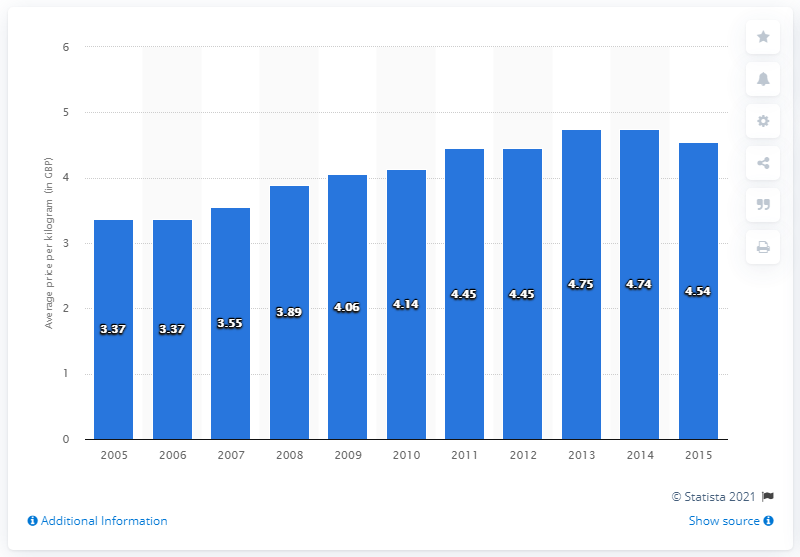Give some essential details in this illustration. The average price paid for poultry meat in British pounds in 2012 was 4.45 pounds. 